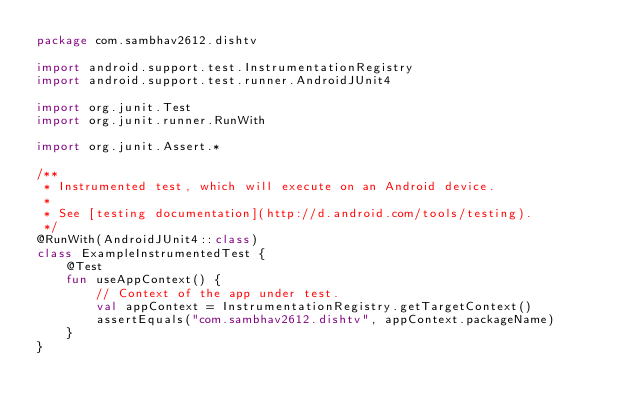<code> <loc_0><loc_0><loc_500><loc_500><_Kotlin_>package com.sambhav2612.dishtv

import android.support.test.InstrumentationRegistry
import android.support.test.runner.AndroidJUnit4

import org.junit.Test
import org.junit.runner.RunWith

import org.junit.Assert.*

/**
 * Instrumented test, which will execute on an Android device.
 *
 * See [testing documentation](http://d.android.com/tools/testing).
 */
@RunWith(AndroidJUnit4::class)
class ExampleInstrumentedTest {
    @Test
    fun useAppContext() {
        // Context of the app under test.
        val appContext = InstrumentationRegistry.getTargetContext()
        assertEquals("com.sambhav2612.dishtv", appContext.packageName)
    }
}
</code> 